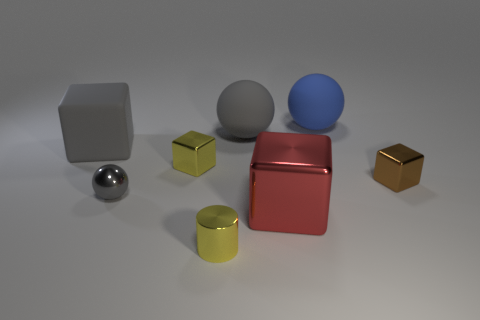What number of other objects are the same size as the blue ball?
Give a very brief answer. 3. What number of tiny things are behind the metal cylinder and in front of the small brown object?
Make the answer very short. 1. Is the object behind the big gray rubber sphere made of the same material as the red thing?
Your answer should be very brief. No. What shape is the large object in front of the large rubber object that is left of the large gray object that is behind the gray rubber block?
Keep it short and to the point. Cube. Is the number of big gray things in front of the small yellow metallic cube the same as the number of objects to the left of the small gray object?
Offer a very short reply. No. The block that is the same size as the brown metal object is what color?
Give a very brief answer. Yellow. How many small things are gray cylinders or gray objects?
Give a very brief answer. 1. There is a object that is both behind the tiny yellow metallic cube and right of the red block; what material is it made of?
Give a very brief answer. Rubber. There is a big object in front of the big gray cube; is its shape the same as the small shiny object on the right side of the small yellow shiny cylinder?
Offer a very short reply. Yes. What shape is the small metallic thing that is the same color as the small cylinder?
Your answer should be very brief. Cube. 